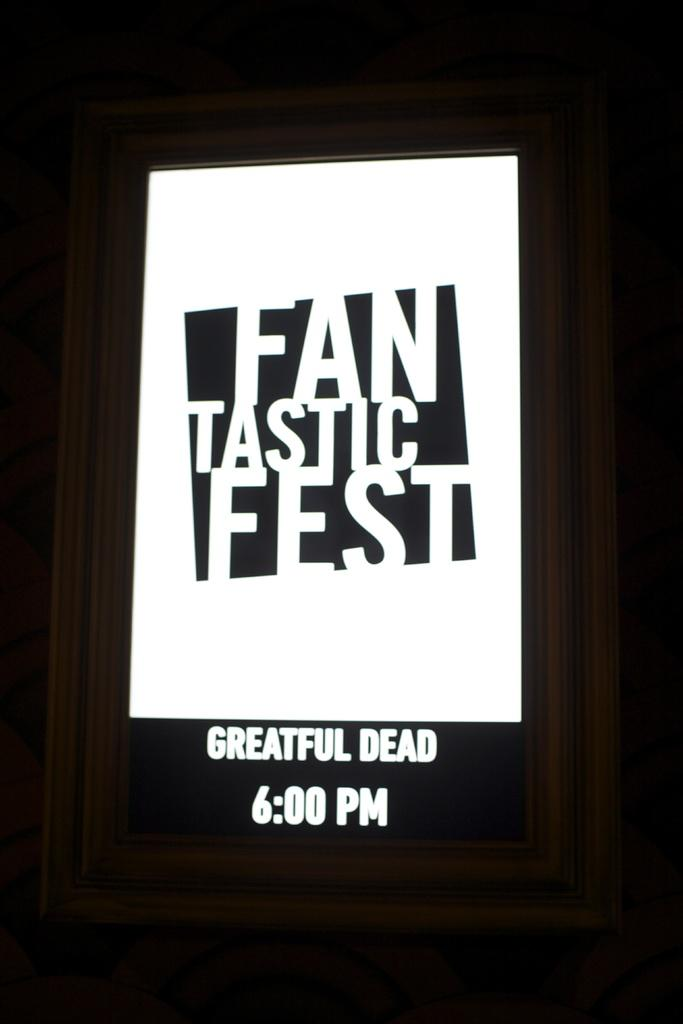What is the main object in the image? There is a screen in the image. What can be seen on the screen? Text is present on the screen, and the time is displayed. How many sisters are depicted on the screen? There are no sisters depicted on the screen; the image only shows a screen with text and the time displayed. 